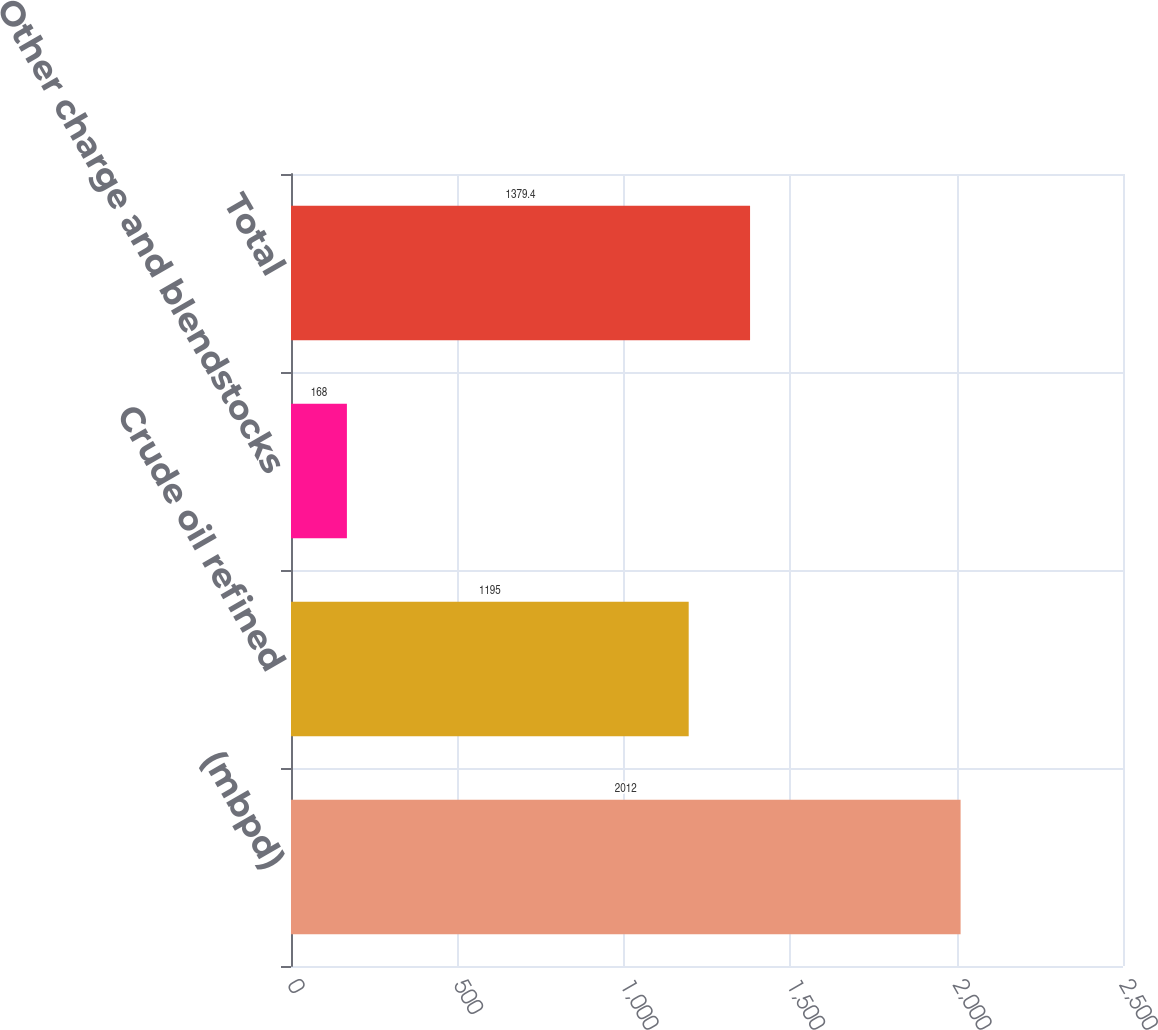<chart> <loc_0><loc_0><loc_500><loc_500><bar_chart><fcel>(mbpd)<fcel>Crude oil refined<fcel>Other charge and blendstocks<fcel>Total<nl><fcel>2012<fcel>1195<fcel>168<fcel>1379.4<nl></chart> 